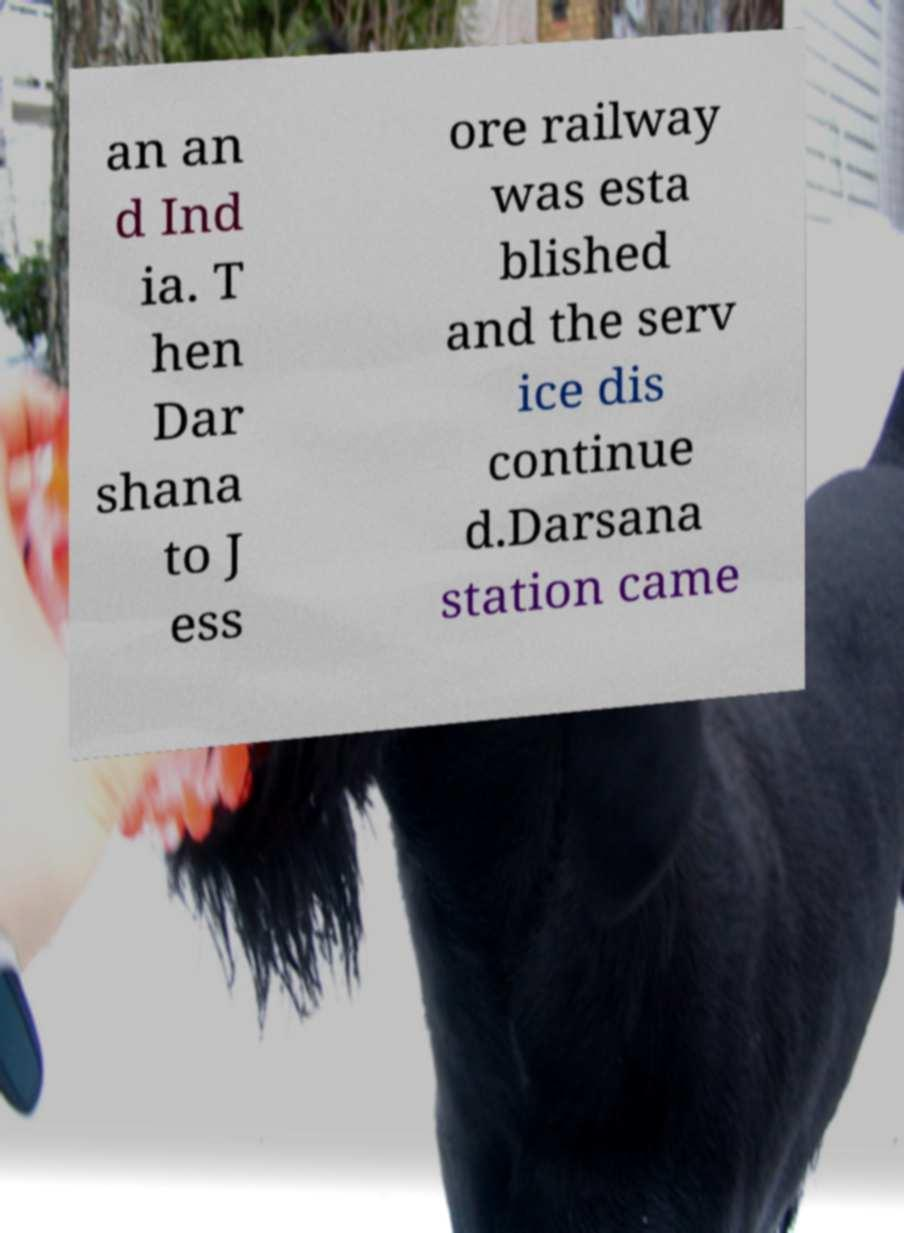Please read and relay the text visible in this image. What does it say? an an d Ind ia. T hen Dar shana to J ess ore railway was esta blished and the serv ice dis continue d.Darsana station came 